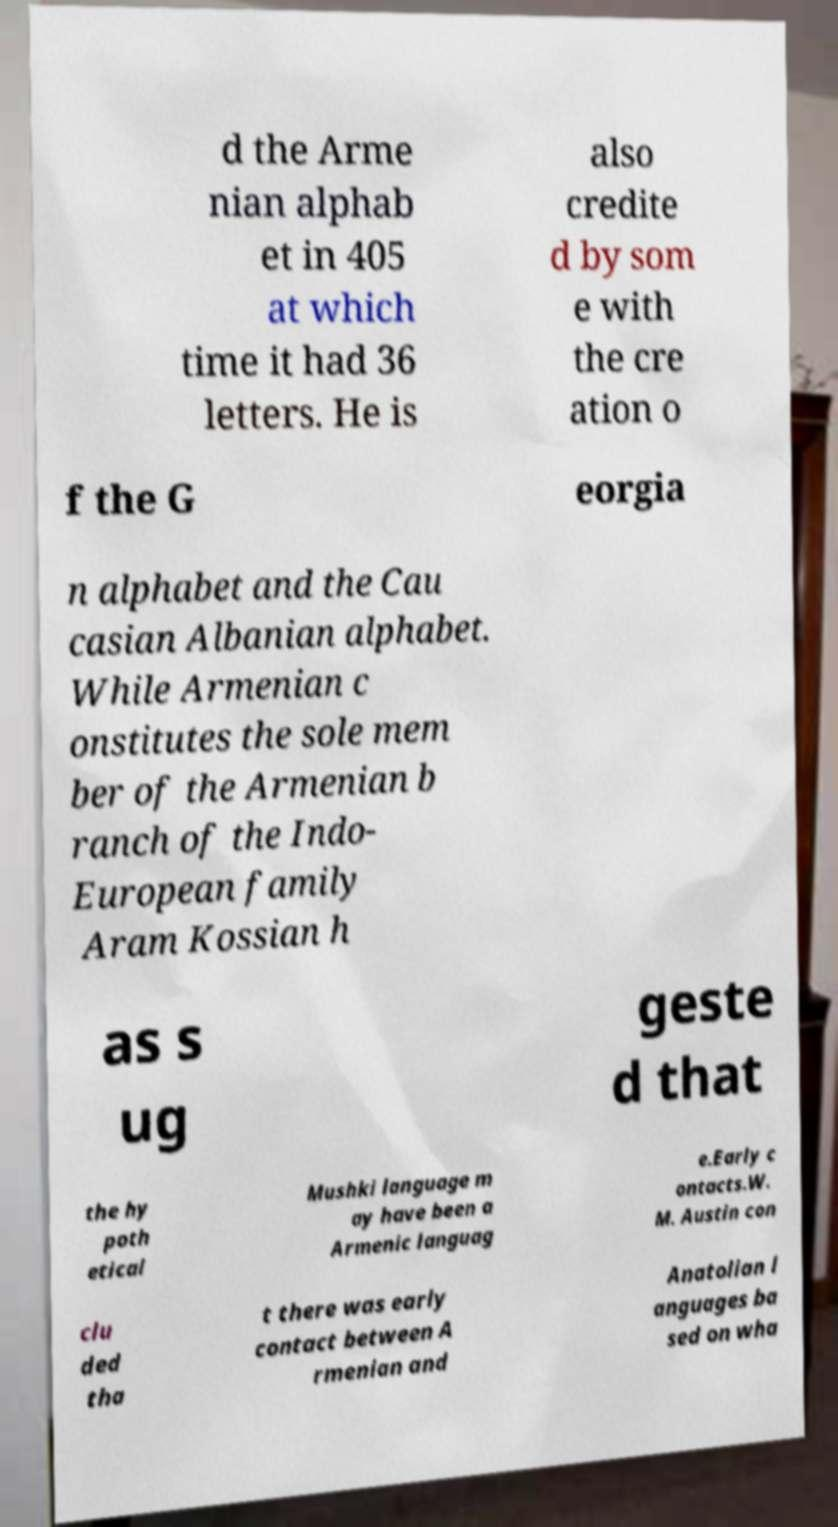Could you assist in decoding the text presented in this image and type it out clearly? d the Arme nian alphab et in 405 at which time it had 36 letters. He is also credite d by som e with the cre ation o f the G eorgia n alphabet and the Cau casian Albanian alphabet. While Armenian c onstitutes the sole mem ber of the Armenian b ranch of the Indo- European family Aram Kossian h as s ug geste d that the hy poth etical Mushki language m ay have been a Armenic languag e.Early c ontacts.W. M. Austin con clu ded tha t there was early contact between A rmenian and Anatolian l anguages ba sed on wha 